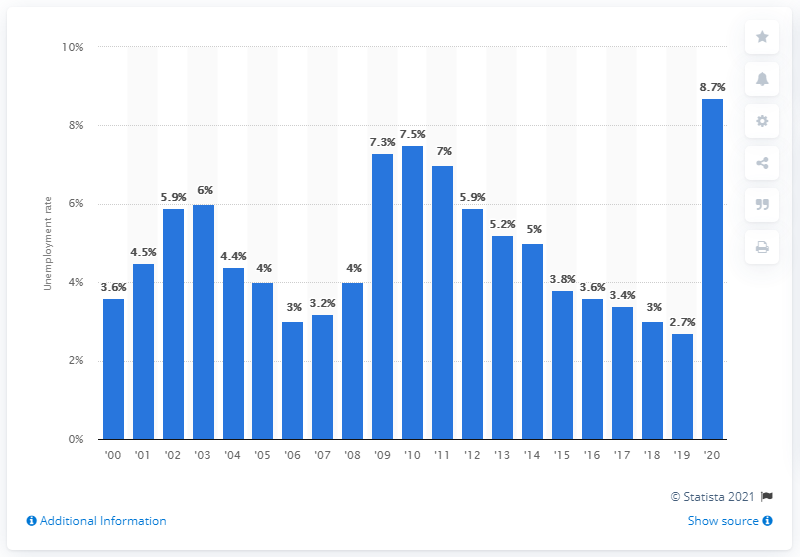Draw attention to some important aspects in this diagram. In 2020, the unemployment rate among Asian Americans was 8.7%. 